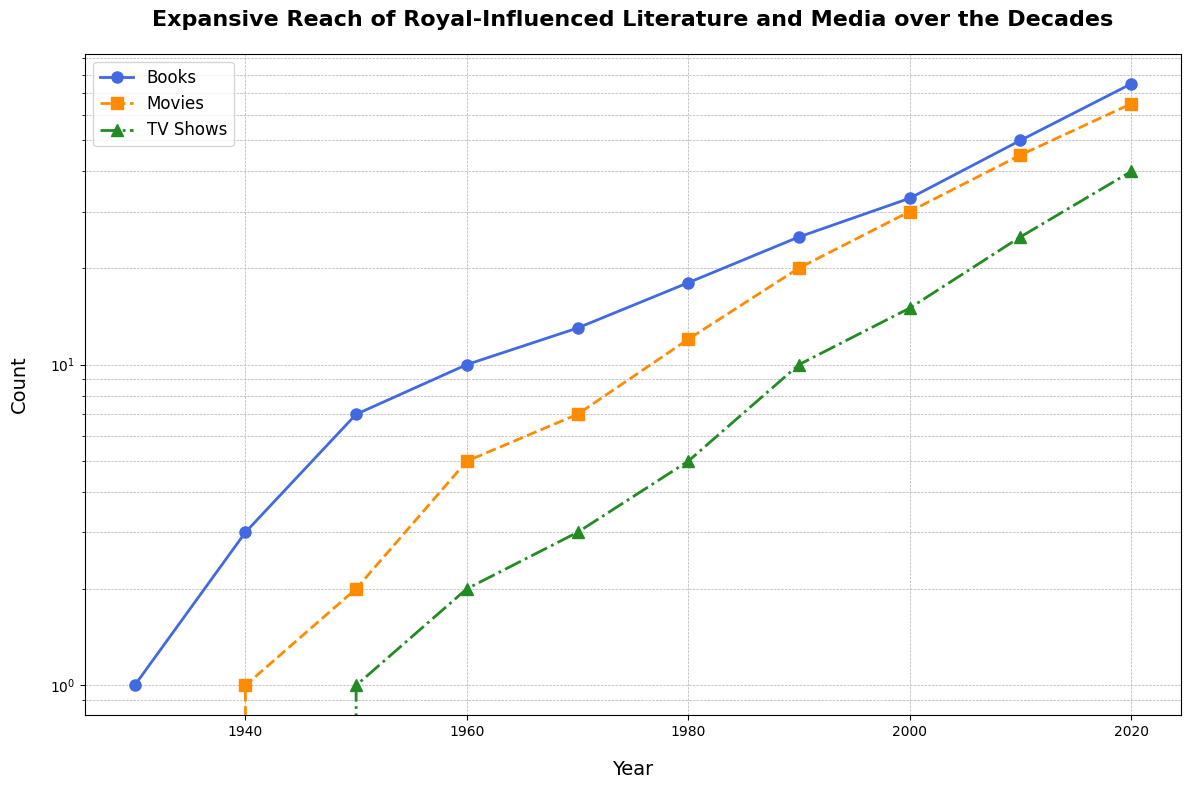What's the growth rate of books between 1930 and 2020? To find the growth rate, divide the number of books in 2020 by the number in 1930, then take the natural log and divide by the number of decades (90 years). There were 75 books in 2020 and 1 book in 1930. So, the growth rate is (ln(75) - ln(1)) / 90.
Answer: Approximately 0.031 How did the number of movies compare between 1940 and 1980? In 1940, there was 1 movie, and in 1980, there were 12 movies. Therefore, the number of movies in 1980 was 12 times the number in 1940.
Answer: 12 times Which type of media showed the most significant increase between 2000 and 2020? By visually inspecting the plot, both books and movies show substantial increases, but books go from 33 to 75, and movies go from 30 to 65. Therefore, books showed the most significant increase.
Answer: Books What is the sum of TV shows across all the decades? Sum the TV shows values: 0 + 0 + 1 + 2 + 3 + 5 + 10 + 15 + 25 + 40. The total is 101.
Answer: 101 Which medium had the highest value in 2020? By inspecting the plot, books had the highest value at 75 in 2020 compared to movies (65) and TV shows (40).
Answer: Books What was the average number of TV shows per decade? Sum the values of TV shows per decade (101) and divide by the number of decades (10). So, 101/10 = 10.1.
Answer: 10.1 In which decade did books surpass 10 units? By inspecting the plot, books exceed 10 between 1960 and 1970. 1960 had 10, so it surpasses in the 1970.
Answer: 1970 What is the difference in the number of TV shows between 1990 and 2010? In 1990, TV shows numbered 10, and in 2010, they numbered 25. The difference is 25 - 10 = 15.
Answer: 15 Which decade saw the highest increase in the number of movies? By comparing each decade, the most significant jump is from 1990 (20 movies) to 2000 (30 movies). The increase is 30 - 20 = 10.
Answer: 1990-2000 What's the ratio of the number of books to TV shows in 2020? In 2020, the number of books is 75, and the number of TV shows is 40. The ratio is 75/40 = 1.875.
Answer: 1.875 